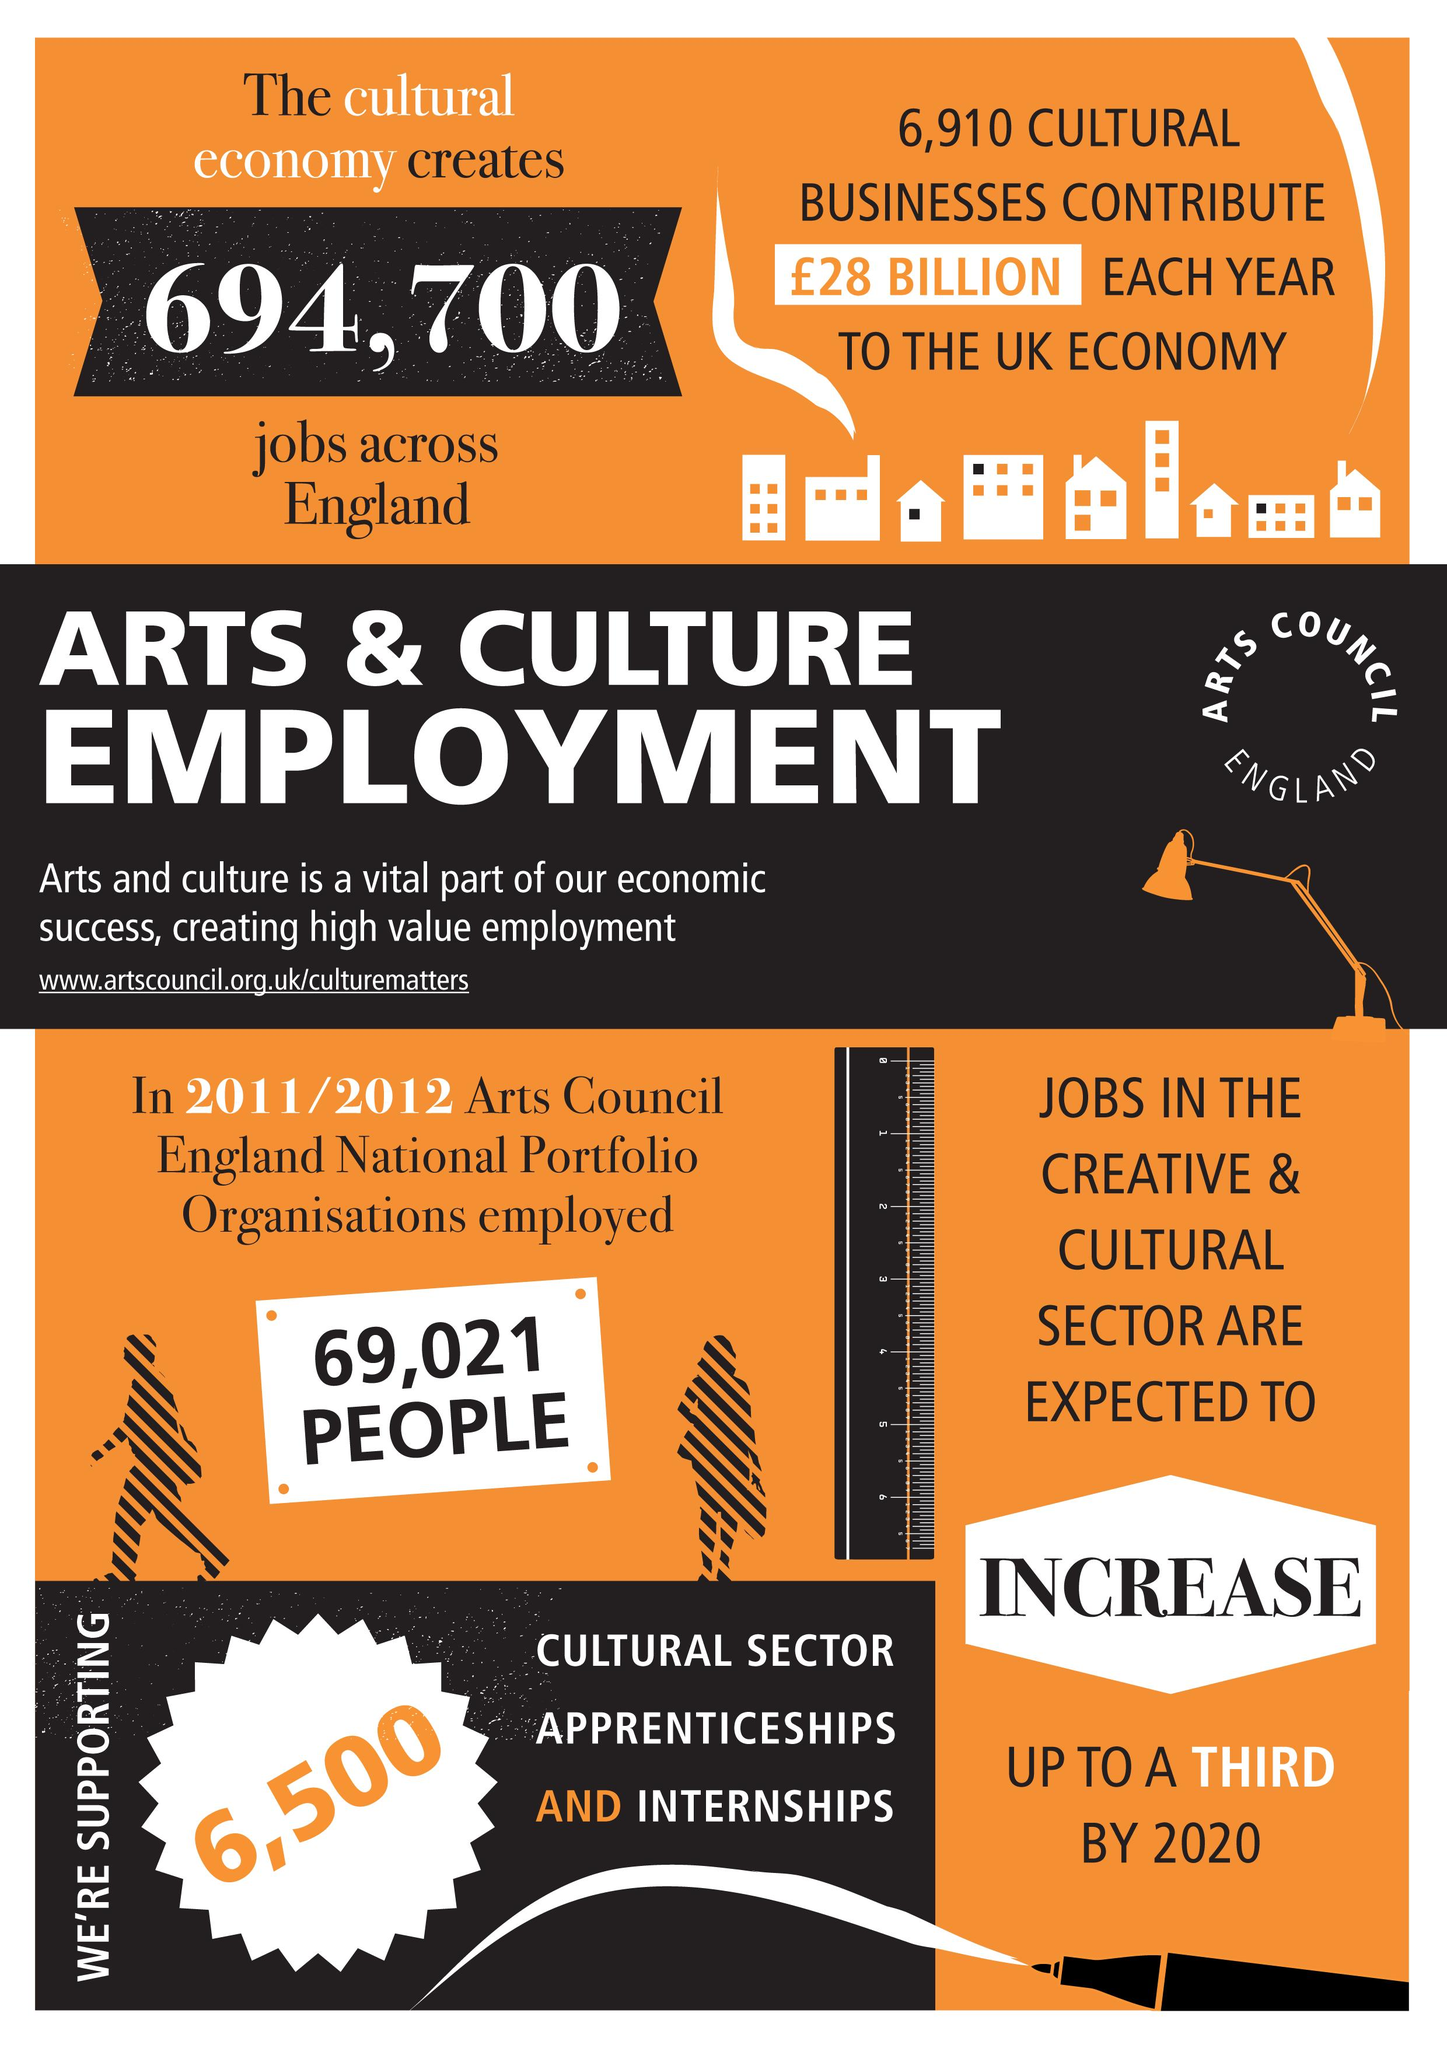Mention a couple of crucial points in this snapshot. In the cultural sector, there were approximately 6,500 apprenticeships and internships offered. According to estimates, cultural economy creates approximately 694,700 jobs in England. The jobs in the creative and cultural sector are projected to increase in the future. 